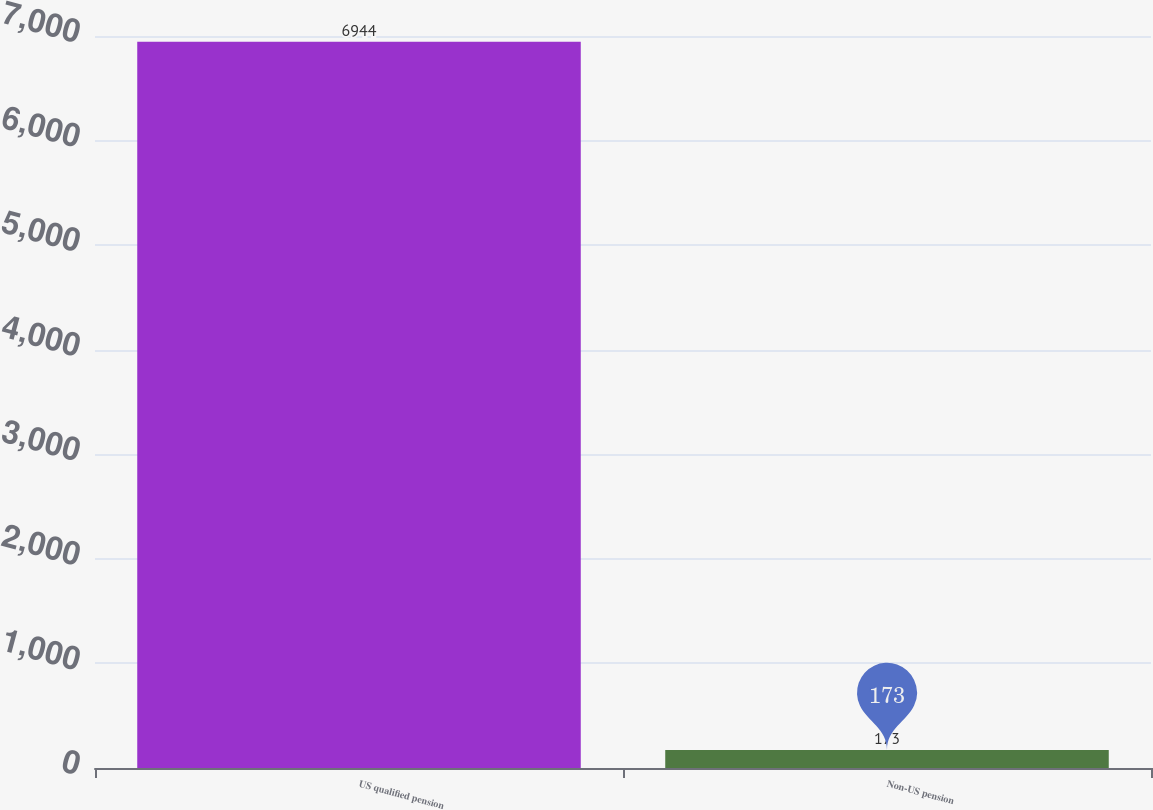<chart> <loc_0><loc_0><loc_500><loc_500><bar_chart><fcel>US qualified pension<fcel>Non-US pension<nl><fcel>6944<fcel>173<nl></chart> 